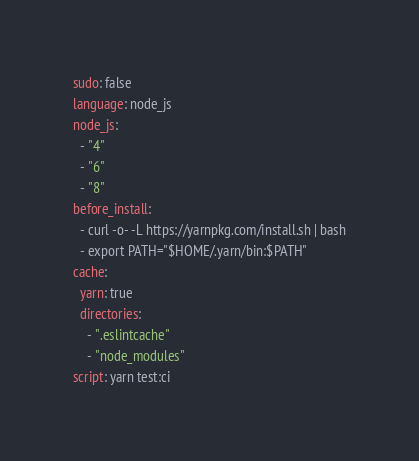<code> <loc_0><loc_0><loc_500><loc_500><_YAML_>sudo: false
language: node_js
node_js:
  - "4"
  - "6"
  - "8"
before_install:
  - curl -o- -L https://yarnpkg.com/install.sh | bash
  - export PATH="$HOME/.yarn/bin:$PATH"
cache:
  yarn: true
  directories:
    - ".eslintcache"
    - "node_modules"
script: yarn test:ci
</code> 